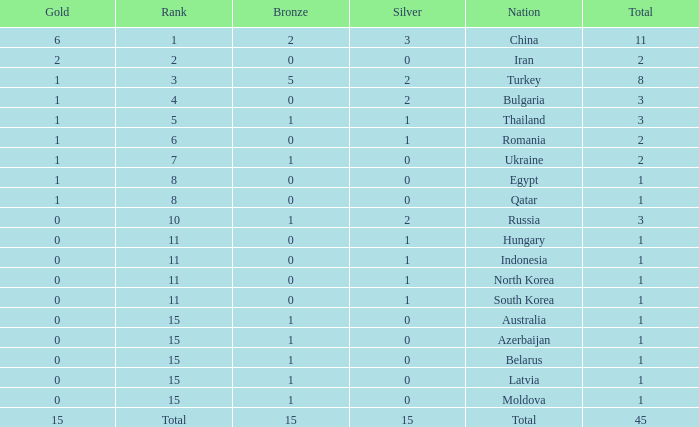What is the sum of the bronze medals of the nation with less than 0 silvers? None. 